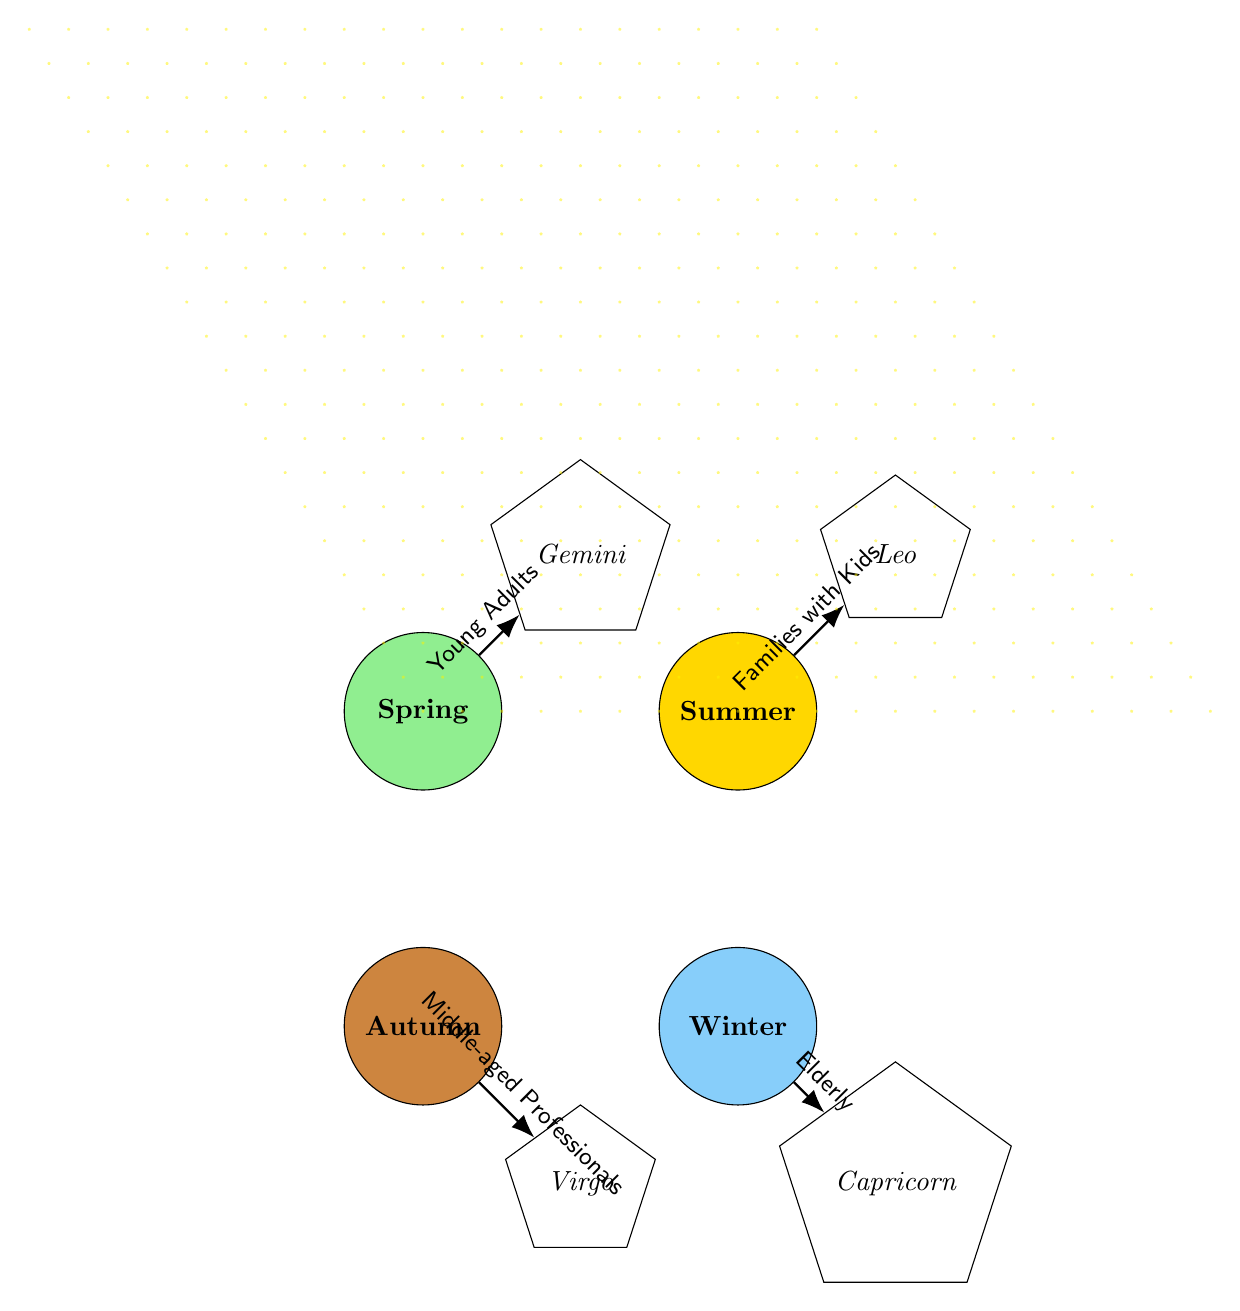What customer segment is associated with Spring? The diagram indicates that the customer segment connected to the Spring node is "Young Adults," as shown by the arrow labeling.
Answer: Young Adults How many seasons are depicted in the diagram? The diagram shows four distinct seasons: Spring, Summer, Autumn, and Winter, each represented by a separate node.
Answer: 4 What constellation is aligned with Summer? In the diagram, the node for Summer is directly connected to the constellation labeled "Leo," which is the only connection for that season.
Answer: Leo Which customer segment corresponds to Winter? The arrow linking the Winter node indicates that "Elderly" is the customer segment related to this season as per the diagram's information.
Answer: Elderly List all the customer segments that appear in the diagram. Examining the connections from each seasonal node reveals the segments: "Young Adults," "Families with Kids," "Middle-aged Professionals," and "Elderly."
Answer: Young Adults, Families with Kids, Middle-aged Professionals, Elderly Which season is connected to Virgo? The diagram’s connections show that Virgo is linked to the Autumn node, indicating that this is the season associated with the Virgo constellation.
Answer: Autumn Identify the season with the highest demographic focus. Analyzing the customer segments reveals that Summer is the only season associated with "Families with Kids," which may suggest a particular focus on this demographic.
Answer: Summer Which customer segment is linked to Capricorn? The diagram indicates that Capricorn is associated with the Winter season, and the customer segment provided is "Elderly." Therefore, the answer is related to this segment.
Answer: Elderly How many constellations are illustrated in the diagram? There are four constellations depicted in the diagram: Gemini, Leo, Virgo, and Capricorn, as shown by the distinct nodes for each constellation.
Answer: 4 